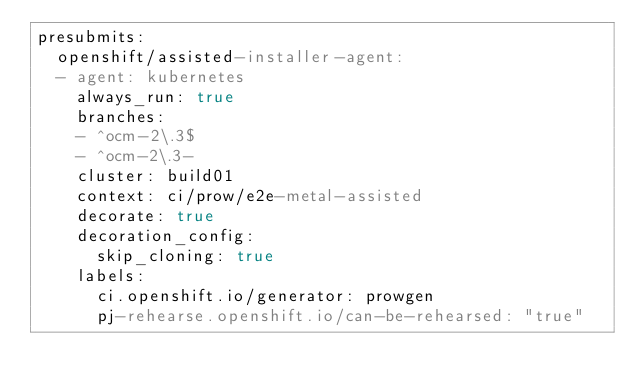Convert code to text. <code><loc_0><loc_0><loc_500><loc_500><_YAML_>presubmits:
  openshift/assisted-installer-agent:
  - agent: kubernetes
    always_run: true
    branches:
    - ^ocm-2\.3$
    - ^ocm-2\.3-
    cluster: build01
    context: ci/prow/e2e-metal-assisted
    decorate: true
    decoration_config:
      skip_cloning: true
    labels:
      ci.openshift.io/generator: prowgen
      pj-rehearse.openshift.io/can-be-rehearsed: "true"</code> 